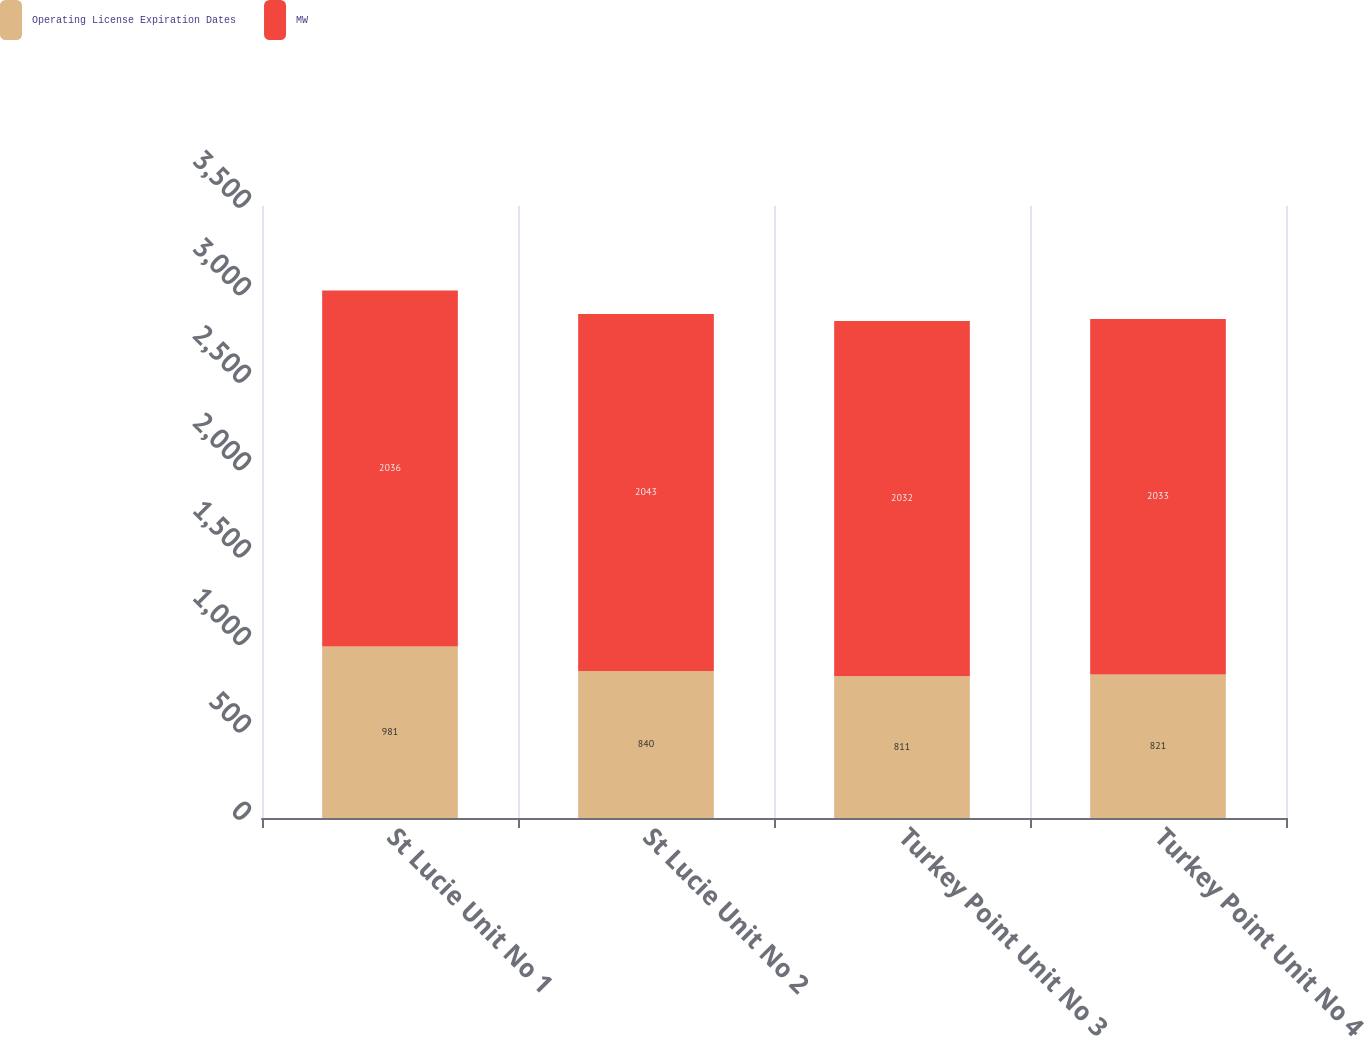<chart> <loc_0><loc_0><loc_500><loc_500><stacked_bar_chart><ecel><fcel>St Lucie Unit No 1<fcel>St Lucie Unit No 2<fcel>Turkey Point Unit No 3<fcel>Turkey Point Unit No 4<nl><fcel>Operating License Expiration Dates<fcel>981<fcel>840<fcel>811<fcel>821<nl><fcel>MW<fcel>2036<fcel>2043<fcel>2032<fcel>2033<nl></chart> 